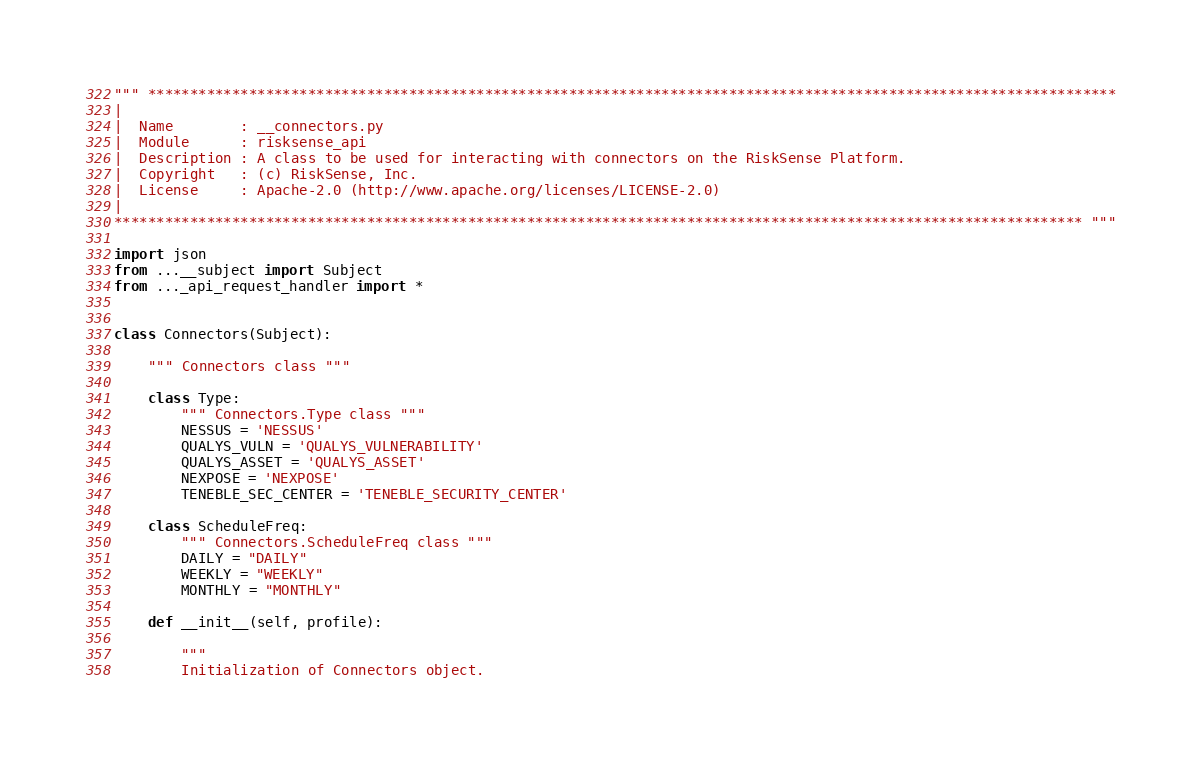<code> <loc_0><loc_0><loc_500><loc_500><_Python_>""" *******************************************************************************************************************
|
|  Name        : __connectors.py
|  Module      : risksense_api
|  Description : A class to be used for interacting with connectors on the RiskSense Platform.
|  Copyright   : (c) RiskSense, Inc.
|  License     : Apache-2.0 (http://www.apache.org/licenses/LICENSE-2.0)
|
******************************************************************************************************************* """

import json
from ...__subject import Subject
from ..._api_request_handler import *


class Connectors(Subject):

    """ Connectors class """

    class Type:
        """ Connectors.Type class """
        NESSUS = 'NESSUS'
        QUALYS_VULN = 'QUALYS_VULNERABILITY'
        QUALYS_ASSET = 'QUALYS_ASSET'
        NEXPOSE = 'NEXPOSE'
        TENEBLE_SEC_CENTER = 'TENEBLE_SECURITY_CENTER'

    class ScheduleFreq:
        """ Connectors.ScheduleFreq class """
        DAILY = "DAILY"
        WEEKLY = "WEEKLY"
        MONTHLY = "MONTHLY"

    def __init__(self, profile):

        """
        Initialization of Connectors object.
</code> 